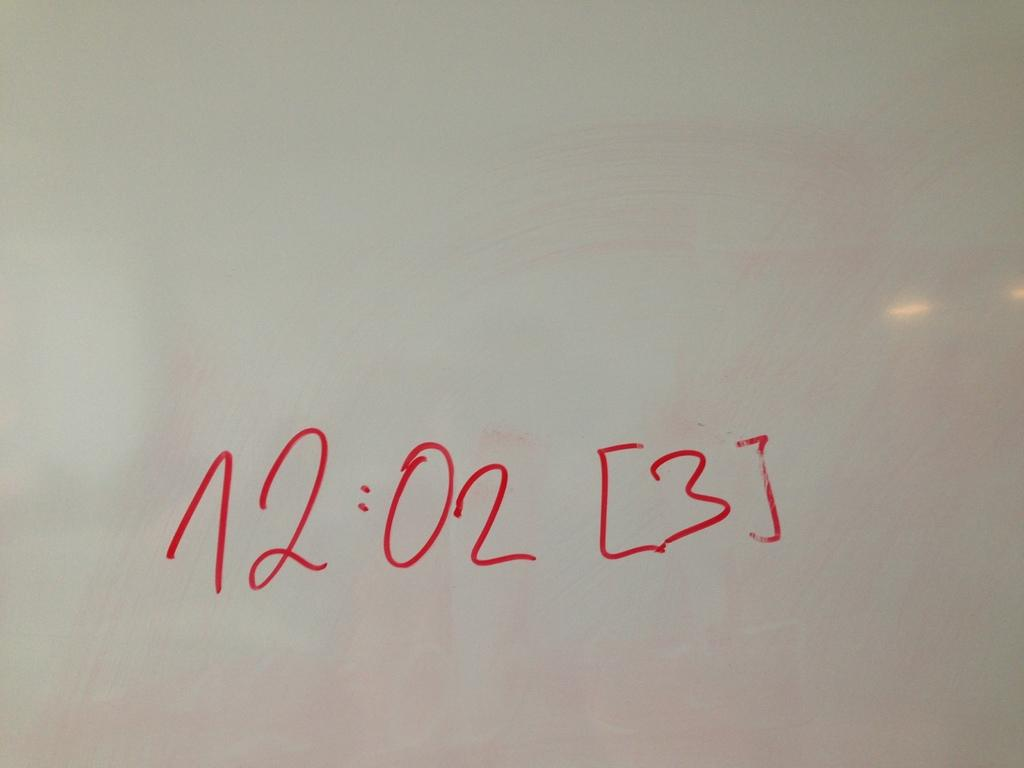Provide a one-sentence caption for the provided image. a white background with the time 12"02 written in red. 